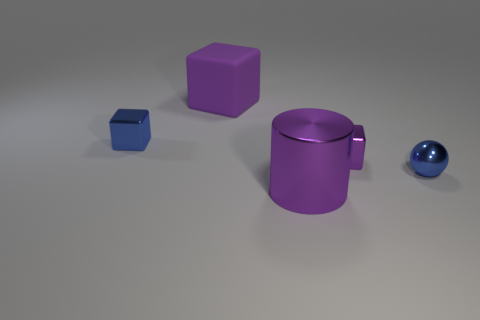Add 5 big brown shiny things. How many objects exist? 10 Subtract all balls. How many objects are left? 4 Subtract all small green metallic spheres. Subtract all tiny blocks. How many objects are left? 3 Add 1 big purple cubes. How many big purple cubes are left? 2 Add 4 big blocks. How many big blocks exist? 5 Subtract 0 yellow spheres. How many objects are left? 5 